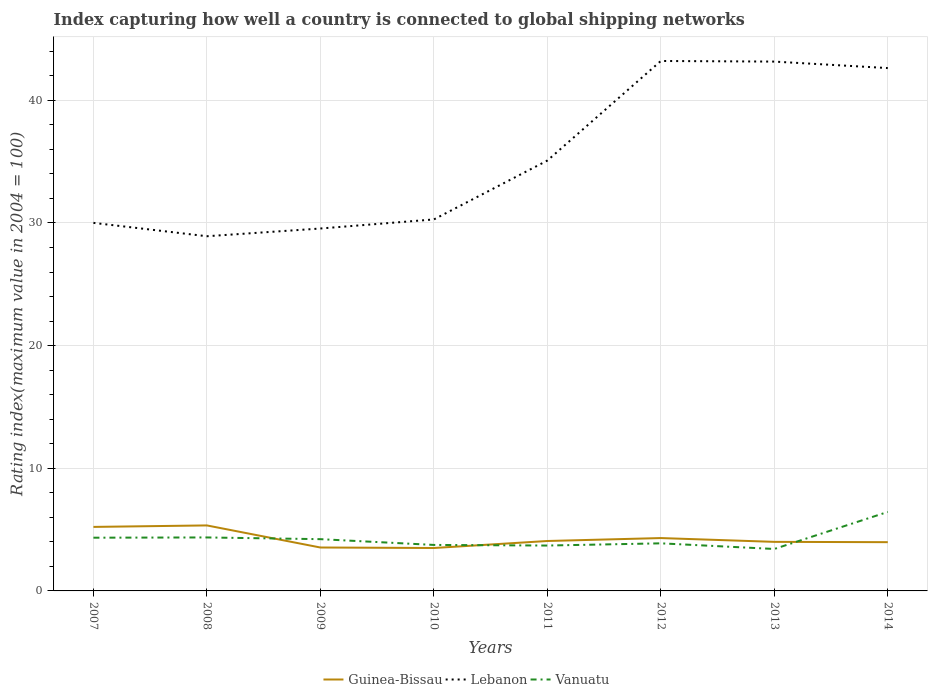How many different coloured lines are there?
Your answer should be very brief. 3. Does the line corresponding to Vanuatu intersect with the line corresponding to Lebanon?
Your answer should be compact. No. Is the number of lines equal to the number of legend labels?
Offer a very short reply. Yes. Across all years, what is the maximum rating index in Guinea-Bissau?
Your answer should be very brief. 3.5. What is the total rating index in Lebanon in the graph?
Offer a very short reply. -12.92. What is the difference between the highest and the second highest rating index in Guinea-Bissau?
Give a very brief answer. 1.84. Is the rating index in Vanuatu strictly greater than the rating index in Lebanon over the years?
Give a very brief answer. Yes. How many years are there in the graph?
Keep it short and to the point. 8. What is the difference between two consecutive major ticks on the Y-axis?
Keep it short and to the point. 10. Does the graph contain any zero values?
Keep it short and to the point. No. Where does the legend appear in the graph?
Make the answer very short. Bottom center. How are the legend labels stacked?
Provide a succinct answer. Horizontal. What is the title of the graph?
Your response must be concise. Index capturing how well a country is connected to global shipping networks. What is the label or title of the Y-axis?
Keep it short and to the point. Rating index(maximum value in 2004 = 100). What is the Rating index(maximum value in 2004 = 100) of Guinea-Bissau in 2007?
Provide a short and direct response. 5.22. What is the Rating index(maximum value in 2004 = 100) of Lebanon in 2007?
Provide a succinct answer. 30.01. What is the Rating index(maximum value in 2004 = 100) in Vanuatu in 2007?
Ensure brevity in your answer.  4.34. What is the Rating index(maximum value in 2004 = 100) of Guinea-Bissau in 2008?
Give a very brief answer. 5.34. What is the Rating index(maximum value in 2004 = 100) of Lebanon in 2008?
Provide a short and direct response. 28.92. What is the Rating index(maximum value in 2004 = 100) in Vanuatu in 2008?
Your answer should be compact. 4.36. What is the Rating index(maximum value in 2004 = 100) of Guinea-Bissau in 2009?
Offer a very short reply. 3.54. What is the Rating index(maximum value in 2004 = 100) in Lebanon in 2009?
Provide a short and direct response. 29.55. What is the Rating index(maximum value in 2004 = 100) of Vanuatu in 2009?
Your answer should be very brief. 4.22. What is the Rating index(maximum value in 2004 = 100) in Lebanon in 2010?
Make the answer very short. 30.29. What is the Rating index(maximum value in 2004 = 100) in Vanuatu in 2010?
Your response must be concise. 3.75. What is the Rating index(maximum value in 2004 = 100) of Guinea-Bissau in 2011?
Your answer should be very brief. 4.07. What is the Rating index(maximum value in 2004 = 100) of Lebanon in 2011?
Offer a terse response. 35.09. What is the Rating index(maximum value in 2004 = 100) in Guinea-Bissau in 2012?
Give a very brief answer. 4.31. What is the Rating index(maximum value in 2004 = 100) in Lebanon in 2012?
Ensure brevity in your answer.  43.21. What is the Rating index(maximum value in 2004 = 100) of Vanuatu in 2012?
Offer a terse response. 3.88. What is the Rating index(maximum value in 2004 = 100) in Guinea-Bissau in 2013?
Your answer should be very brief. 4. What is the Rating index(maximum value in 2004 = 100) in Lebanon in 2013?
Your answer should be very brief. 43.16. What is the Rating index(maximum value in 2004 = 100) of Vanuatu in 2013?
Your answer should be very brief. 3.42. What is the Rating index(maximum value in 2004 = 100) of Guinea-Bissau in 2014?
Your answer should be very brief. 3.97. What is the Rating index(maximum value in 2004 = 100) of Lebanon in 2014?
Your response must be concise. 42.63. What is the Rating index(maximum value in 2004 = 100) in Vanuatu in 2014?
Make the answer very short. 6.44. Across all years, what is the maximum Rating index(maximum value in 2004 = 100) in Guinea-Bissau?
Give a very brief answer. 5.34. Across all years, what is the maximum Rating index(maximum value in 2004 = 100) of Lebanon?
Your response must be concise. 43.21. Across all years, what is the maximum Rating index(maximum value in 2004 = 100) of Vanuatu?
Your response must be concise. 6.44. Across all years, what is the minimum Rating index(maximum value in 2004 = 100) of Lebanon?
Keep it short and to the point. 28.92. Across all years, what is the minimum Rating index(maximum value in 2004 = 100) of Vanuatu?
Your answer should be very brief. 3.42. What is the total Rating index(maximum value in 2004 = 100) of Guinea-Bissau in the graph?
Ensure brevity in your answer.  33.95. What is the total Rating index(maximum value in 2004 = 100) in Lebanon in the graph?
Provide a succinct answer. 282.86. What is the total Rating index(maximum value in 2004 = 100) of Vanuatu in the graph?
Provide a succinct answer. 34.11. What is the difference between the Rating index(maximum value in 2004 = 100) of Guinea-Bissau in 2007 and that in 2008?
Provide a short and direct response. -0.12. What is the difference between the Rating index(maximum value in 2004 = 100) of Lebanon in 2007 and that in 2008?
Offer a terse response. 1.09. What is the difference between the Rating index(maximum value in 2004 = 100) in Vanuatu in 2007 and that in 2008?
Your answer should be very brief. -0.02. What is the difference between the Rating index(maximum value in 2004 = 100) of Guinea-Bissau in 2007 and that in 2009?
Offer a terse response. 1.68. What is the difference between the Rating index(maximum value in 2004 = 100) in Lebanon in 2007 and that in 2009?
Offer a very short reply. 0.46. What is the difference between the Rating index(maximum value in 2004 = 100) in Vanuatu in 2007 and that in 2009?
Your response must be concise. 0.12. What is the difference between the Rating index(maximum value in 2004 = 100) in Guinea-Bissau in 2007 and that in 2010?
Your answer should be compact. 1.72. What is the difference between the Rating index(maximum value in 2004 = 100) of Lebanon in 2007 and that in 2010?
Keep it short and to the point. -0.28. What is the difference between the Rating index(maximum value in 2004 = 100) in Vanuatu in 2007 and that in 2010?
Your answer should be very brief. 0.59. What is the difference between the Rating index(maximum value in 2004 = 100) in Guinea-Bissau in 2007 and that in 2011?
Make the answer very short. 1.15. What is the difference between the Rating index(maximum value in 2004 = 100) in Lebanon in 2007 and that in 2011?
Keep it short and to the point. -5.08. What is the difference between the Rating index(maximum value in 2004 = 100) of Vanuatu in 2007 and that in 2011?
Offer a very short reply. 0.64. What is the difference between the Rating index(maximum value in 2004 = 100) in Guinea-Bissau in 2007 and that in 2012?
Make the answer very short. 0.91. What is the difference between the Rating index(maximum value in 2004 = 100) in Vanuatu in 2007 and that in 2012?
Offer a terse response. 0.46. What is the difference between the Rating index(maximum value in 2004 = 100) in Guinea-Bissau in 2007 and that in 2013?
Ensure brevity in your answer.  1.22. What is the difference between the Rating index(maximum value in 2004 = 100) of Lebanon in 2007 and that in 2013?
Give a very brief answer. -13.15. What is the difference between the Rating index(maximum value in 2004 = 100) of Guinea-Bissau in 2007 and that in 2014?
Provide a succinct answer. 1.25. What is the difference between the Rating index(maximum value in 2004 = 100) in Lebanon in 2007 and that in 2014?
Make the answer very short. -12.62. What is the difference between the Rating index(maximum value in 2004 = 100) of Vanuatu in 2007 and that in 2014?
Provide a short and direct response. -2.1. What is the difference between the Rating index(maximum value in 2004 = 100) of Lebanon in 2008 and that in 2009?
Keep it short and to the point. -0.63. What is the difference between the Rating index(maximum value in 2004 = 100) in Vanuatu in 2008 and that in 2009?
Your response must be concise. 0.14. What is the difference between the Rating index(maximum value in 2004 = 100) in Guinea-Bissau in 2008 and that in 2010?
Your answer should be compact. 1.84. What is the difference between the Rating index(maximum value in 2004 = 100) in Lebanon in 2008 and that in 2010?
Keep it short and to the point. -1.37. What is the difference between the Rating index(maximum value in 2004 = 100) of Vanuatu in 2008 and that in 2010?
Make the answer very short. 0.61. What is the difference between the Rating index(maximum value in 2004 = 100) in Guinea-Bissau in 2008 and that in 2011?
Provide a short and direct response. 1.27. What is the difference between the Rating index(maximum value in 2004 = 100) in Lebanon in 2008 and that in 2011?
Provide a succinct answer. -6.17. What is the difference between the Rating index(maximum value in 2004 = 100) of Vanuatu in 2008 and that in 2011?
Provide a succinct answer. 0.66. What is the difference between the Rating index(maximum value in 2004 = 100) in Lebanon in 2008 and that in 2012?
Your answer should be very brief. -14.29. What is the difference between the Rating index(maximum value in 2004 = 100) in Vanuatu in 2008 and that in 2012?
Keep it short and to the point. 0.48. What is the difference between the Rating index(maximum value in 2004 = 100) of Guinea-Bissau in 2008 and that in 2013?
Provide a succinct answer. 1.34. What is the difference between the Rating index(maximum value in 2004 = 100) in Lebanon in 2008 and that in 2013?
Your answer should be very brief. -14.24. What is the difference between the Rating index(maximum value in 2004 = 100) of Guinea-Bissau in 2008 and that in 2014?
Ensure brevity in your answer.  1.37. What is the difference between the Rating index(maximum value in 2004 = 100) of Lebanon in 2008 and that in 2014?
Offer a terse response. -13.71. What is the difference between the Rating index(maximum value in 2004 = 100) in Vanuatu in 2008 and that in 2014?
Ensure brevity in your answer.  -2.08. What is the difference between the Rating index(maximum value in 2004 = 100) in Guinea-Bissau in 2009 and that in 2010?
Provide a succinct answer. 0.04. What is the difference between the Rating index(maximum value in 2004 = 100) in Lebanon in 2009 and that in 2010?
Make the answer very short. -0.74. What is the difference between the Rating index(maximum value in 2004 = 100) of Vanuatu in 2009 and that in 2010?
Give a very brief answer. 0.47. What is the difference between the Rating index(maximum value in 2004 = 100) in Guinea-Bissau in 2009 and that in 2011?
Provide a succinct answer. -0.53. What is the difference between the Rating index(maximum value in 2004 = 100) of Lebanon in 2009 and that in 2011?
Ensure brevity in your answer.  -5.54. What is the difference between the Rating index(maximum value in 2004 = 100) in Vanuatu in 2009 and that in 2011?
Ensure brevity in your answer.  0.52. What is the difference between the Rating index(maximum value in 2004 = 100) in Guinea-Bissau in 2009 and that in 2012?
Your answer should be compact. -0.77. What is the difference between the Rating index(maximum value in 2004 = 100) in Lebanon in 2009 and that in 2012?
Your answer should be compact. -13.66. What is the difference between the Rating index(maximum value in 2004 = 100) of Vanuatu in 2009 and that in 2012?
Offer a terse response. 0.34. What is the difference between the Rating index(maximum value in 2004 = 100) in Guinea-Bissau in 2009 and that in 2013?
Offer a very short reply. -0.46. What is the difference between the Rating index(maximum value in 2004 = 100) of Lebanon in 2009 and that in 2013?
Keep it short and to the point. -13.61. What is the difference between the Rating index(maximum value in 2004 = 100) of Guinea-Bissau in 2009 and that in 2014?
Keep it short and to the point. -0.43. What is the difference between the Rating index(maximum value in 2004 = 100) in Lebanon in 2009 and that in 2014?
Your response must be concise. -13.08. What is the difference between the Rating index(maximum value in 2004 = 100) of Vanuatu in 2009 and that in 2014?
Provide a short and direct response. -2.22. What is the difference between the Rating index(maximum value in 2004 = 100) of Guinea-Bissau in 2010 and that in 2011?
Your answer should be compact. -0.57. What is the difference between the Rating index(maximum value in 2004 = 100) of Lebanon in 2010 and that in 2011?
Your answer should be very brief. -4.8. What is the difference between the Rating index(maximum value in 2004 = 100) of Vanuatu in 2010 and that in 2011?
Your response must be concise. 0.05. What is the difference between the Rating index(maximum value in 2004 = 100) in Guinea-Bissau in 2010 and that in 2012?
Provide a short and direct response. -0.81. What is the difference between the Rating index(maximum value in 2004 = 100) in Lebanon in 2010 and that in 2012?
Ensure brevity in your answer.  -12.92. What is the difference between the Rating index(maximum value in 2004 = 100) in Vanuatu in 2010 and that in 2012?
Your answer should be compact. -0.13. What is the difference between the Rating index(maximum value in 2004 = 100) in Lebanon in 2010 and that in 2013?
Ensure brevity in your answer.  -12.87. What is the difference between the Rating index(maximum value in 2004 = 100) of Vanuatu in 2010 and that in 2013?
Offer a very short reply. 0.33. What is the difference between the Rating index(maximum value in 2004 = 100) in Guinea-Bissau in 2010 and that in 2014?
Your answer should be very brief. -0.47. What is the difference between the Rating index(maximum value in 2004 = 100) of Lebanon in 2010 and that in 2014?
Your answer should be compact. -12.34. What is the difference between the Rating index(maximum value in 2004 = 100) of Vanuatu in 2010 and that in 2014?
Ensure brevity in your answer.  -2.69. What is the difference between the Rating index(maximum value in 2004 = 100) of Guinea-Bissau in 2011 and that in 2012?
Your answer should be very brief. -0.24. What is the difference between the Rating index(maximum value in 2004 = 100) in Lebanon in 2011 and that in 2012?
Your response must be concise. -8.12. What is the difference between the Rating index(maximum value in 2004 = 100) of Vanuatu in 2011 and that in 2012?
Your response must be concise. -0.18. What is the difference between the Rating index(maximum value in 2004 = 100) of Guinea-Bissau in 2011 and that in 2013?
Offer a terse response. 0.07. What is the difference between the Rating index(maximum value in 2004 = 100) in Lebanon in 2011 and that in 2013?
Make the answer very short. -8.07. What is the difference between the Rating index(maximum value in 2004 = 100) in Vanuatu in 2011 and that in 2013?
Offer a terse response. 0.28. What is the difference between the Rating index(maximum value in 2004 = 100) in Guinea-Bissau in 2011 and that in 2014?
Give a very brief answer. 0.1. What is the difference between the Rating index(maximum value in 2004 = 100) in Lebanon in 2011 and that in 2014?
Keep it short and to the point. -7.54. What is the difference between the Rating index(maximum value in 2004 = 100) of Vanuatu in 2011 and that in 2014?
Provide a short and direct response. -2.74. What is the difference between the Rating index(maximum value in 2004 = 100) of Guinea-Bissau in 2012 and that in 2013?
Provide a short and direct response. 0.31. What is the difference between the Rating index(maximum value in 2004 = 100) in Lebanon in 2012 and that in 2013?
Your answer should be compact. 0.05. What is the difference between the Rating index(maximum value in 2004 = 100) of Vanuatu in 2012 and that in 2013?
Offer a terse response. 0.46. What is the difference between the Rating index(maximum value in 2004 = 100) of Guinea-Bissau in 2012 and that in 2014?
Offer a very short reply. 0.34. What is the difference between the Rating index(maximum value in 2004 = 100) of Lebanon in 2012 and that in 2014?
Keep it short and to the point. 0.58. What is the difference between the Rating index(maximum value in 2004 = 100) of Vanuatu in 2012 and that in 2014?
Make the answer very short. -2.56. What is the difference between the Rating index(maximum value in 2004 = 100) of Guinea-Bissau in 2013 and that in 2014?
Provide a succinct answer. 0.03. What is the difference between the Rating index(maximum value in 2004 = 100) in Lebanon in 2013 and that in 2014?
Your answer should be compact. 0.53. What is the difference between the Rating index(maximum value in 2004 = 100) of Vanuatu in 2013 and that in 2014?
Ensure brevity in your answer.  -3.02. What is the difference between the Rating index(maximum value in 2004 = 100) of Guinea-Bissau in 2007 and the Rating index(maximum value in 2004 = 100) of Lebanon in 2008?
Your answer should be compact. -23.7. What is the difference between the Rating index(maximum value in 2004 = 100) in Guinea-Bissau in 2007 and the Rating index(maximum value in 2004 = 100) in Vanuatu in 2008?
Offer a terse response. 0.86. What is the difference between the Rating index(maximum value in 2004 = 100) of Lebanon in 2007 and the Rating index(maximum value in 2004 = 100) of Vanuatu in 2008?
Offer a terse response. 25.65. What is the difference between the Rating index(maximum value in 2004 = 100) in Guinea-Bissau in 2007 and the Rating index(maximum value in 2004 = 100) in Lebanon in 2009?
Make the answer very short. -24.33. What is the difference between the Rating index(maximum value in 2004 = 100) of Lebanon in 2007 and the Rating index(maximum value in 2004 = 100) of Vanuatu in 2009?
Make the answer very short. 25.79. What is the difference between the Rating index(maximum value in 2004 = 100) of Guinea-Bissau in 2007 and the Rating index(maximum value in 2004 = 100) of Lebanon in 2010?
Keep it short and to the point. -25.07. What is the difference between the Rating index(maximum value in 2004 = 100) in Guinea-Bissau in 2007 and the Rating index(maximum value in 2004 = 100) in Vanuatu in 2010?
Give a very brief answer. 1.47. What is the difference between the Rating index(maximum value in 2004 = 100) in Lebanon in 2007 and the Rating index(maximum value in 2004 = 100) in Vanuatu in 2010?
Provide a short and direct response. 26.26. What is the difference between the Rating index(maximum value in 2004 = 100) of Guinea-Bissau in 2007 and the Rating index(maximum value in 2004 = 100) of Lebanon in 2011?
Your answer should be very brief. -29.87. What is the difference between the Rating index(maximum value in 2004 = 100) in Guinea-Bissau in 2007 and the Rating index(maximum value in 2004 = 100) in Vanuatu in 2011?
Ensure brevity in your answer.  1.52. What is the difference between the Rating index(maximum value in 2004 = 100) of Lebanon in 2007 and the Rating index(maximum value in 2004 = 100) of Vanuatu in 2011?
Your answer should be compact. 26.31. What is the difference between the Rating index(maximum value in 2004 = 100) in Guinea-Bissau in 2007 and the Rating index(maximum value in 2004 = 100) in Lebanon in 2012?
Keep it short and to the point. -37.99. What is the difference between the Rating index(maximum value in 2004 = 100) in Guinea-Bissau in 2007 and the Rating index(maximum value in 2004 = 100) in Vanuatu in 2012?
Provide a short and direct response. 1.34. What is the difference between the Rating index(maximum value in 2004 = 100) in Lebanon in 2007 and the Rating index(maximum value in 2004 = 100) in Vanuatu in 2012?
Provide a succinct answer. 26.13. What is the difference between the Rating index(maximum value in 2004 = 100) of Guinea-Bissau in 2007 and the Rating index(maximum value in 2004 = 100) of Lebanon in 2013?
Make the answer very short. -37.94. What is the difference between the Rating index(maximum value in 2004 = 100) of Lebanon in 2007 and the Rating index(maximum value in 2004 = 100) of Vanuatu in 2013?
Provide a short and direct response. 26.59. What is the difference between the Rating index(maximum value in 2004 = 100) of Guinea-Bissau in 2007 and the Rating index(maximum value in 2004 = 100) of Lebanon in 2014?
Your response must be concise. -37.41. What is the difference between the Rating index(maximum value in 2004 = 100) in Guinea-Bissau in 2007 and the Rating index(maximum value in 2004 = 100) in Vanuatu in 2014?
Your answer should be very brief. -1.22. What is the difference between the Rating index(maximum value in 2004 = 100) of Lebanon in 2007 and the Rating index(maximum value in 2004 = 100) of Vanuatu in 2014?
Provide a short and direct response. 23.57. What is the difference between the Rating index(maximum value in 2004 = 100) of Guinea-Bissau in 2008 and the Rating index(maximum value in 2004 = 100) of Lebanon in 2009?
Your response must be concise. -24.21. What is the difference between the Rating index(maximum value in 2004 = 100) in Guinea-Bissau in 2008 and the Rating index(maximum value in 2004 = 100) in Vanuatu in 2009?
Keep it short and to the point. 1.12. What is the difference between the Rating index(maximum value in 2004 = 100) of Lebanon in 2008 and the Rating index(maximum value in 2004 = 100) of Vanuatu in 2009?
Give a very brief answer. 24.7. What is the difference between the Rating index(maximum value in 2004 = 100) in Guinea-Bissau in 2008 and the Rating index(maximum value in 2004 = 100) in Lebanon in 2010?
Offer a terse response. -24.95. What is the difference between the Rating index(maximum value in 2004 = 100) of Guinea-Bissau in 2008 and the Rating index(maximum value in 2004 = 100) of Vanuatu in 2010?
Ensure brevity in your answer.  1.59. What is the difference between the Rating index(maximum value in 2004 = 100) of Lebanon in 2008 and the Rating index(maximum value in 2004 = 100) of Vanuatu in 2010?
Offer a very short reply. 25.17. What is the difference between the Rating index(maximum value in 2004 = 100) in Guinea-Bissau in 2008 and the Rating index(maximum value in 2004 = 100) in Lebanon in 2011?
Your answer should be compact. -29.75. What is the difference between the Rating index(maximum value in 2004 = 100) of Guinea-Bissau in 2008 and the Rating index(maximum value in 2004 = 100) of Vanuatu in 2011?
Keep it short and to the point. 1.64. What is the difference between the Rating index(maximum value in 2004 = 100) in Lebanon in 2008 and the Rating index(maximum value in 2004 = 100) in Vanuatu in 2011?
Your response must be concise. 25.22. What is the difference between the Rating index(maximum value in 2004 = 100) of Guinea-Bissau in 2008 and the Rating index(maximum value in 2004 = 100) of Lebanon in 2012?
Offer a very short reply. -37.87. What is the difference between the Rating index(maximum value in 2004 = 100) of Guinea-Bissau in 2008 and the Rating index(maximum value in 2004 = 100) of Vanuatu in 2012?
Provide a short and direct response. 1.46. What is the difference between the Rating index(maximum value in 2004 = 100) in Lebanon in 2008 and the Rating index(maximum value in 2004 = 100) in Vanuatu in 2012?
Your answer should be very brief. 25.04. What is the difference between the Rating index(maximum value in 2004 = 100) of Guinea-Bissau in 2008 and the Rating index(maximum value in 2004 = 100) of Lebanon in 2013?
Give a very brief answer. -37.82. What is the difference between the Rating index(maximum value in 2004 = 100) in Guinea-Bissau in 2008 and the Rating index(maximum value in 2004 = 100) in Vanuatu in 2013?
Give a very brief answer. 1.92. What is the difference between the Rating index(maximum value in 2004 = 100) of Guinea-Bissau in 2008 and the Rating index(maximum value in 2004 = 100) of Lebanon in 2014?
Keep it short and to the point. -37.29. What is the difference between the Rating index(maximum value in 2004 = 100) of Guinea-Bissau in 2008 and the Rating index(maximum value in 2004 = 100) of Vanuatu in 2014?
Offer a terse response. -1.1. What is the difference between the Rating index(maximum value in 2004 = 100) of Lebanon in 2008 and the Rating index(maximum value in 2004 = 100) of Vanuatu in 2014?
Offer a terse response. 22.48. What is the difference between the Rating index(maximum value in 2004 = 100) in Guinea-Bissau in 2009 and the Rating index(maximum value in 2004 = 100) in Lebanon in 2010?
Provide a short and direct response. -26.75. What is the difference between the Rating index(maximum value in 2004 = 100) in Guinea-Bissau in 2009 and the Rating index(maximum value in 2004 = 100) in Vanuatu in 2010?
Ensure brevity in your answer.  -0.21. What is the difference between the Rating index(maximum value in 2004 = 100) in Lebanon in 2009 and the Rating index(maximum value in 2004 = 100) in Vanuatu in 2010?
Make the answer very short. 25.8. What is the difference between the Rating index(maximum value in 2004 = 100) of Guinea-Bissau in 2009 and the Rating index(maximum value in 2004 = 100) of Lebanon in 2011?
Your answer should be very brief. -31.55. What is the difference between the Rating index(maximum value in 2004 = 100) of Guinea-Bissau in 2009 and the Rating index(maximum value in 2004 = 100) of Vanuatu in 2011?
Your answer should be compact. -0.16. What is the difference between the Rating index(maximum value in 2004 = 100) of Lebanon in 2009 and the Rating index(maximum value in 2004 = 100) of Vanuatu in 2011?
Make the answer very short. 25.85. What is the difference between the Rating index(maximum value in 2004 = 100) in Guinea-Bissau in 2009 and the Rating index(maximum value in 2004 = 100) in Lebanon in 2012?
Offer a very short reply. -39.67. What is the difference between the Rating index(maximum value in 2004 = 100) in Guinea-Bissau in 2009 and the Rating index(maximum value in 2004 = 100) in Vanuatu in 2012?
Offer a terse response. -0.34. What is the difference between the Rating index(maximum value in 2004 = 100) of Lebanon in 2009 and the Rating index(maximum value in 2004 = 100) of Vanuatu in 2012?
Make the answer very short. 25.67. What is the difference between the Rating index(maximum value in 2004 = 100) of Guinea-Bissau in 2009 and the Rating index(maximum value in 2004 = 100) of Lebanon in 2013?
Your answer should be compact. -39.62. What is the difference between the Rating index(maximum value in 2004 = 100) in Guinea-Bissau in 2009 and the Rating index(maximum value in 2004 = 100) in Vanuatu in 2013?
Keep it short and to the point. 0.12. What is the difference between the Rating index(maximum value in 2004 = 100) in Lebanon in 2009 and the Rating index(maximum value in 2004 = 100) in Vanuatu in 2013?
Offer a terse response. 26.13. What is the difference between the Rating index(maximum value in 2004 = 100) of Guinea-Bissau in 2009 and the Rating index(maximum value in 2004 = 100) of Lebanon in 2014?
Your response must be concise. -39.09. What is the difference between the Rating index(maximum value in 2004 = 100) of Guinea-Bissau in 2009 and the Rating index(maximum value in 2004 = 100) of Vanuatu in 2014?
Your response must be concise. -2.9. What is the difference between the Rating index(maximum value in 2004 = 100) of Lebanon in 2009 and the Rating index(maximum value in 2004 = 100) of Vanuatu in 2014?
Your response must be concise. 23.11. What is the difference between the Rating index(maximum value in 2004 = 100) of Guinea-Bissau in 2010 and the Rating index(maximum value in 2004 = 100) of Lebanon in 2011?
Make the answer very short. -31.59. What is the difference between the Rating index(maximum value in 2004 = 100) in Guinea-Bissau in 2010 and the Rating index(maximum value in 2004 = 100) in Vanuatu in 2011?
Make the answer very short. -0.2. What is the difference between the Rating index(maximum value in 2004 = 100) in Lebanon in 2010 and the Rating index(maximum value in 2004 = 100) in Vanuatu in 2011?
Ensure brevity in your answer.  26.59. What is the difference between the Rating index(maximum value in 2004 = 100) in Guinea-Bissau in 2010 and the Rating index(maximum value in 2004 = 100) in Lebanon in 2012?
Give a very brief answer. -39.71. What is the difference between the Rating index(maximum value in 2004 = 100) of Guinea-Bissau in 2010 and the Rating index(maximum value in 2004 = 100) of Vanuatu in 2012?
Your answer should be very brief. -0.38. What is the difference between the Rating index(maximum value in 2004 = 100) in Lebanon in 2010 and the Rating index(maximum value in 2004 = 100) in Vanuatu in 2012?
Your answer should be compact. 26.41. What is the difference between the Rating index(maximum value in 2004 = 100) of Guinea-Bissau in 2010 and the Rating index(maximum value in 2004 = 100) of Lebanon in 2013?
Provide a short and direct response. -39.66. What is the difference between the Rating index(maximum value in 2004 = 100) in Lebanon in 2010 and the Rating index(maximum value in 2004 = 100) in Vanuatu in 2013?
Your response must be concise. 26.87. What is the difference between the Rating index(maximum value in 2004 = 100) of Guinea-Bissau in 2010 and the Rating index(maximum value in 2004 = 100) of Lebanon in 2014?
Provide a short and direct response. -39.13. What is the difference between the Rating index(maximum value in 2004 = 100) of Guinea-Bissau in 2010 and the Rating index(maximum value in 2004 = 100) of Vanuatu in 2014?
Ensure brevity in your answer.  -2.94. What is the difference between the Rating index(maximum value in 2004 = 100) of Lebanon in 2010 and the Rating index(maximum value in 2004 = 100) of Vanuatu in 2014?
Ensure brevity in your answer.  23.85. What is the difference between the Rating index(maximum value in 2004 = 100) of Guinea-Bissau in 2011 and the Rating index(maximum value in 2004 = 100) of Lebanon in 2012?
Give a very brief answer. -39.14. What is the difference between the Rating index(maximum value in 2004 = 100) in Guinea-Bissau in 2011 and the Rating index(maximum value in 2004 = 100) in Vanuatu in 2012?
Offer a very short reply. 0.19. What is the difference between the Rating index(maximum value in 2004 = 100) of Lebanon in 2011 and the Rating index(maximum value in 2004 = 100) of Vanuatu in 2012?
Your answer should be compact. 31.21. What is the difference between the Rating index(maximum value in 2004 = 100) in Guinea-Bissau in 2011 and the Rating index(maximum value in 2004 = 100) in Lebanon in 2013?
Keep it short and to the point. -39.09. What is the difference between the Rating index(maximum value in 2004 = 100) of Guinea-Bissau in 2011 and the Rating index(maximum value in 2004 = 100) of Vanuatu in 2013?
Your answer should be compact. 0.65. What is the difference between the Rating index(maximum value in 2004 = 100) in Lebanon in 2011 and the Rating index(maximum value in 2004 = 100) in Vanuatu in 2013?
Your answer should be very brief. 31.67. What is the difference between the Rating index(maximum value in 2004 = 100) of Guinea-Bissau in 2011 and the Rating index(maximum value in 2004 = 100) of Lebanon in 2014?
Give a very brief answer. -38.56. What is the difference between the Rating index(maximum value in 2004 = 100) in Guinea-Bissau in 2011 and the Rating index(maximum value in 2004 = 100) in Vanuatu in 2014?
Give a very brief answer. -2.37. What is the difference between the Rating index(maximum value in 2004 = 100) of Lebanon in 2011 and the Rating index(maximum value in 2004 = 100) of Vanuatu in 2014?
Give a very brief answer. 28.65. What is the difference between the Rating index(maximum value in 2004 = 100) in Guinea-Bissau in 2012 and the Rating index(maximum value in 2004 = 100) in Lebanon in 2013?
Give a very brief answer. -38.85. What is the difference between the Rating index(maximum value in 2004 = 100) of Guinea-Bissau in 2012 and the Rating index(maximum value in 2004 = 100) of Vanuatu in 2013?
Your response must be concise. 0.89. What is the difference between the Rating index(maximum value in 2004 = 100) of Lebanon in 2012 and the Rating index(maximum value in 2004 = 100) of Vanuatu in 2013?
Provide a succinct answer. 39.79. What is the difference between the Rating index(maximum value in 2004 = 100) of Guinea-Bissau in 2012 and the Rating index(maximum value in 2004 = 100) of Lebanon in 2014?
Keep it short and to the point. -38.32. What is the difference between the Rating index(maximum value in 2004 = 100) of Guinea-Bissau in 2012 and the Rating index(maximum value in 2004 = 100) of Vanuatu in 2014?
Offer a very short reply. -2.13. What is the difference between the Rating index(maximum value in 2004 = 100) in Lebanon in 2012 and the Rating index(maximum value in 2004 = 100) in Vanuatu in 2014?
Ensure brevity in your answer.  36.77. What is the difference between the Rating index(maximum value in 2004 = 100) of Guinea-Bissau in 2013 and the Rating index(maximum value in 2004 = 100) of Lebanon in 2014?
Provide a succinct answer. -38.63. What is the difference between the Rating index(maximum value in 2004 = 100) in Guinea-Bissau in 2013 and the Rating index(maximum value in 2004 = 100) in Vanuatu in 2014?
Offer a terse response. -2.44. What is the difference between the Rating index(maximum value in 2004 = 100) of Lebanon in 2013 and the Rating index(maximum value in 2004 = 100) of Vanuatu in 2014?
Your response must be concise. 36.72. What is the average Rating index(maximum value in 2004 = 100) in Guinea-Bissau per year?
Ensure brevity in your answer.  4.24. What is the average Rating index(maximum value in 2004 = 100) in Lebanon per year?
Provide a succinct answer. 35.36. What is the average Rating index(maximum value in 2004 = 100) of Vanuatu per year?
Your response must be concise. 4.26. In the year 2007, what is the difference between the Rating index(maximum value in 2004 = 100) of Guinea-Bissau and Rating index(maximum value in 2004 = 100) of Lebanon?
Give a very brief answer. -24.79. In the year 2007, what is the difference between the Rating index(maximum value in 2004 = 100) of Lebanon and Rating index(maximum value in 2004 = 100) of Vanuatu?
Keep it short and to the point. 25.67. In the year 2008, what is the difference between the Rating index(maximum value in 2004 = 100) of Guinea-Bissau and Rating index(maximum value in 2004 = 100) of Lebanon?
Ensure brevity in your answer.  -23.58. In the year 2008, what is the difference between the Rating index(maximum value in 2004 = 100) of Lebanon and Rating index(maximum value in 2004 = 100) of Vanuatu?
Make the answer very short. 24.56. In the year 2009, what is the difference between the Rating index(maximum value in 2004 = 100) in Guinea-Bissau and Rating index(maximum value in 2004 = 100) in Lebanon?
Keep it short and to the point. -26.01. In the year 2009, what is the difference between the Rating index(maximum value in 2004 = 100) of Guinea-Bissau and Rating index(maximum value in 2004 = 100) of Vanuatu?
Provide a succinct answer. -0.68. In the year 2009, what is the difference between the Rating index(maximum value in 2004 = 100) of Lebanon and Rating index(maximum value in 2004 = 100) of Vanuatu?
Make the answer very short. 25.33. In the year 2010, what is the difference between the Rating index(maximum value in 2004 = 100) of Guinea-Bissau and Rating index(maximum value in 2004 = 100) of Lebanon?
Offer a very short reply. -26.79. In the year 2010, what is the difference between the Rating index(maximum value in 2004 = 100) of Lebanon and Rating index(maximum value in 2004 = 100) of Vanuatu?
Give a very brief answer. 26.54. In the year 2011, what is the difference between the Rating index(maximum value in 2004 = 100) of Guinea-Bissau and Rating index(maximum value in 2004 = 100) of Lebanon?
Offer a very short reply. -31.02. In the year 2011, what is the difference between the Rating index(maximum value in 2004 = 100) in Guinea-Bissau and Rating index(maximum value in 2004 = 100) in Vanuatu?
Your answer should be compact. 0.37. In the year 2011, what is the difference between the Rating index(maximum value in 2004 = 100) in Lebanon and Rating index(maximum value in 2004 = 100) in Vanuatu?
Give a very brief answer. 31.39. In the year 2012, what is the difference between the Rating index(maximum value in 2004 = 100) in Guinea-Bissau and Rating index(maximum value in 2004 = 100) in Lebanon?
Your answer should be compact. -38.9. In the year 2012, what is the difference between the Rating index(maximum value in 2004 = 100) in Guinea-Bissau and Rating index(maximum value in 2004 = 100) in Vanuatu?
Keep it short and to the point. 0.43. In the year 2012, what is the difference between the Rating index(maximum value in 2004 = 100) in Lebanon and Rating index(maximum value in 2004 = 100) in Vanuatu?
Provide a short and direct response. 39.33. In the year 2013, what is the difference between the Rating index(maximum value in 2004 = 100) in Guinea-Bissau and Rating index(maximum value in 2004 = 100) in Lebanon?
Offer a very short reply. -39.16. In the year 2013, what is the difference between the Rating index(maximum value in 2004 = 100) of Guinea-Bissau and Rating index(maximum value in 2004 = 100) of Vanuatu?
Your response must be concise. 0.58. In the year 2013, what is the difference between the Rating index(maximum value in 2004 = 100) in Lebanon and Rating index(maximum value in 2004 = 100) in Vanuatu?
Provide a succinct answer. 39.74. In the year 2014, what is the difference between the Rating index(maximum value in 2004 = 100) in Guinea-Bissau and Rating index(maximum value in 2004 = 100) in Lebanon?
Provide a succinct answer. -38.66. In the year 2014, what is the difference between the Rating index(maximum value in 2004 = 100) of Guinea-Bissau and Rating index(maximum value in 2004 = 100) of Vanuatu?
Offer a terse response. -2.47. In the year 2014, what is the difference between the Rating index(maximum value in 2004 = 100) in Lebanon and Rating index(maximum value in 2004 = 100) in Vanuatu?
Make the answer very short. 36.19. What is the ratio of the Rating index(maximum value in 2004 = 100) of Guinea-Bissau in 2007 to that in 2008?
Keep it short and to the point. 0.98. What is the ratio of the Rating index(maximum value in 2004 = 100) in Lebanon in 2007 to that in 2008?
Give a very brief answer. 1.04. What is the ratio of the Rating index(maximum value in 2004 = 100) in Vanuatu in 2007 to that in 2008?
Your answer should be compact. 1. What is the ratio of the Rating index(maximum value in 2004 = 100) in Guinea-Bissau in 2007 to that in 2009?
Give a very brief answer. 1.47. What is the ratio of the Rating index(maximum value in 2004 = 100) in Lebanon in 2007 to that in 2009?
Offer a terse response. 1.02. What is the ratio of the Rating index(maximum value in 2004 = 100) of Vanuatu in 2007 to that in 2009?
Your response must be concise. 1.03. What is the ratio of the Rating index(maximum value in 2004 = 100) in Guinea-Bissau in 2007 to that in 2010?
Your response must be concise. 1.49. What is the ratio of the Rating index(maximum value in 2004 = 100) in Vanuatu in 2007 to that in 2010?
Ensure brevity in your answer.  1.16. What is the ratio of the Rating index(maximum value in 2004 = 100) of Guinea-Bissau in 2007 to that in 2011?
Keep it short and to the point. 1.28. What is the ratio of the Rating index(maximum value in 2004 = 100) of Lebanon in 2007 to that in 2011?
Offer a very short reply. 0.86. What is the ratio of the Rating index(maximum value in 2004 = 100) in Vanuatu in 2007 to that in 2011?
Offer a terse response. 1.17. What is the ratio of the Rating index(maximum value in 2004 = 100) in Guinea-Bissau in 2007 to that in 2012?
Make the answer very short. 1.21. What is the ratio of the Rating index(maximum value in 2004 = 100) in Lebanon in 2007 to that in 2012?
Ensure brevity in your answer.  0.69. What is the ratio of the Rating index(maximum value in 2004 = 100) in Vanuatu in 2007 to that in 2012?
Ensure brevity in your answer.  1.12. What is the ratio of the Rating index(maximum value in 2004 = 100) in Guinea-Bissau in 2007 to that in 2013?
Make the answer very short. 1.3. What is the ratio of the Rating index(maximum value in 2004 = 100) in Lebanon in 2007 to that in 2013?
Keep it short and to the point. 0.7. What is the ratio of the Rating index(maximum value in 2004 = 100) of Vanuatu in 2007 to that in 2013?
Give a very brief answer. 1.27. What is the ratio of the Rating index(maximum value in 2004 = 100) in Guinea-Bissau in 2007 to that in 2014?
Provide a short and direct response. 1.31. What is the ratio of the Rating index(maximum value in 2004 = 100) in Lebanon in 2007 to that in 2014?
Offer a very short reply. 0.7. What is the ratio of the Rating index(maximum value in 2004 = 100) of Vanuatu in 2007 to that in 2014?
Provide a succinct answer. 0.67. What is the ratio of the Rating index(maximum value in 2004 = 100) in Guinea-Bissau in 2008 to that in 2009?
Your answer should be very brief. 1.51. What is the ratio of the Rating index(maximum value in 2004 = 100) of Lebanon in 2008 to that in 2009?
Keep it short and to the point. 0.98. What is the ratio of the Rating index(maximum value in 2004 = 100) of Vanuatu in 2008 to that in 2009?
Offer a terse response. 1.03. What is the ratio of the Rating index(maximum value in 2004 = 100) in Guinea-Bissau in 2008 to that in 2010?
Provide a short and direct response. 1.53. What is the ratio of the Rating index(maximum value in 2004 = 100) of Lebanon in 2008 to that in 2010?
Give a very brief answer. 0.95. What is the ratio of the Rating index(maximum value in 2004 = 100) of Vanuatu in 2008 to that in 2010?
Your answer should be compact. 1.16. What is the ratio of the Rating index(maximum value in 2004 = 100) of Guinea-Bissau in 2008 to that in 2011?
Make the answer very short. 1.31. What is the ratio of the Rating index(maximum value in 2004 = 100) of Lebanon in 2008 to that in 2011?
Keep it short and to the point. 0.82. What is the ratio of the Rating index(maximum value in 2004 = 100) of Vanuatu in 2008 to that in 2011?
Ensure brevity in your answer.  1.18. What is the ratio of the Rating index(maximum value in 2004 = 100) in Guinea-Bissau in 2008 to that in 2012?
Make the answer very short. 1.24. What is the ratio of the Rating index(maximum value in 2004 = 100) in Lebanon in 2008 to that in 2012?
Keep it short and to the point. 0.67. What is the ratio of the Rating index(maximum value in 2004 = 100) of Vanuatu in 2008 to that in 2012?
Your answer should be compact. 1.12. What is the ratio of the Rating index(maximum value in 2004 = 100) in Guinea-Bissau in 2008 to that in 2013?
Your response must be concise. 1.33. What is the ratio of the Rating index(maximum value in 2004 = 100) of Lebanon in 2008 to that in 2013?
Give a very brief answer. 0.67. What is the ratio of the Rating index(maximum value in 2004 = 100) of Vanuatu in 2008 to that in 2013?
Your answer should be compact. 1.27. What is the ratio of the Rating index(maximum value in 2004 = 100) of Guinea-Bissau in 2008 to that in 2014?
Keep it short and to the point. 1.34. What is the ratio of the Rating index(maximum value in 2004 = 100) in Lebanon in 2008 to that in 2014?
Your answer should be compact. 0.68. What is the ratio of the Rating index(maximum value in 2004 = 100) in Vanuatu in 2008 to that in 2014?
Offer a very short reply. 0.68. What is the ratio of the Rating index(maximum value in 2004 = 100) of Guinea-Bissau in 2009 to that in 2010?
Ensure brevity in your answer.  1.01. What is the ratio of the Rating index(maximum value in 2004 = 100) of Lebanon in 2009 to that in 2010?
Your answer should be compact. 0.98. What is the ratio of the Rating index(maximum value in 2004 = 100) of Vanuatu in 2009 to that in 2010?
Offer a very short reply. 1.13. What is the ratio of the Rating index(maximum value in 2004 = 100) of Guinea-Bissau in 2009 to that in 2011?
Offer a terse response. 0.87. What is the ratio of the Rating index(maximum value in 2004 = 100) of Lebanon in 2009 to that in 2011?
Offer a very short reply. 0.84. What is the ratio of the Rating index(maximum value in 2004 = 100) of Vanuatu in 2009 to that in 2011?
Keep it short and to the point. 1.14. What is the ratio of the Rating index(maximum value in 2004 = 100) in Guinea-Bissau in 2009 to that in 2012?
Offer a terse response. 0.82. What is the ratio of the Rating index(maximum value in 2004 = 100) in Lebanon in 2009 to that in 2012?
Ensure brevity in your answer.  0.68. What is the ratio of the Rating index(maximum value in 2004 = 100) in Vanuatu in 2009 to that in 2012?
Offer a very short reply. 1.09. What is the ratio of the Rating index(maximum value in 2004 = 100) of Guinea-Bissau in 2009 to that in 2013?
Keep it short and to the point. 0.89. What is the ratio of the Rating index(maximum value in 2004 = 100) in Lebanon in 2009 to that in 2013?
Provide a short and direct response. 0.68. What is the ratio of the Rating index(maximum value in 2004 = 100) in Vanuatu in 2009 to that in 2013?
Give a very brief answer. 1.23. What is the ratio of the Rating index(maximum value in 2004 = 100) of Guinea-Bissau in 2009 to that in 2014?
Offer a terse response. 0.89. What is the ratio of the Rating index(maximum value in 2004 = 100) in Lebanon in 2009 to that in 2014?
Make the answer very short. 0.69. What is the ratio of the Rating index(maximum value in 2004 = 100) of Vanuatu in 2009 to that in 2014?
Offer a very short reply. 0.66. What is the ratio of the Rating index(maximum value in 2004 = 100) of Guinea-Bissau in 2010 to that in 2011?
Keep it short and to the point. 0.86. What is the ratio of the Rating index(maximum value in 2004 = 100) in Lebanon in 2010 to that in 2011?
Provide a short and direct response. 0.86. What is the ratio of the Rating index(maximum value in 2004 = 100) in Vanuatu in 2010 to that in 2011?
Your answer should be compact. 1.01. What is the ratio of the Rating index(maximum value in 2004 = 100) of Guinea-Bissau in 2010 to that in 2012?
Provide a succinct answer. 0.81. What is the ratio of the Rating index(maximum value in 2004 = 100) of Lebanon in 2010 to that in 2012?
Ensure brevity in your answer.  0.7. What is the ratio of the Rating index(maximum value in 2004 = 100) in Vanuatu in 2010 to that in 2012?
Offer a terse response. 0.97. What is the ratio of the Rating index(maximum value in 2004 = 100) of Lebanon in 2010 to that in 2013?
Provide a succinct answer. 0.7. What is the ratio of the Rating index(maximum value in 2004 = 100) of Vanuatu in 2010 to that in 2013?
Offer a terse response. 1.1. What is the ratio of the Rating index(maximum value in 2004 = 100) in Guinea-Bissau in 2010 to that in 2014?
Give a very brief answer. 0.88. What is the ratio of the Rating index(maximum value in 2004 = 100) in Lebanon in 2010 to that in 2014?
Give a very brief answer. 0.71. What is the ratio of the Rating index(maximum value in 2004 = 100) of Vanuatu in 2010 to that in 2014?
Ensure brevity in your answer.  0.58. What is the ratio of the Rating index(maximum value in 2004 = 100) of Guinea-Bissau in 2011 to that in 2012?
Your answer should be compact. 0.94. What is the ratio of the Rating index(maximum value in 2004 = 100) of Lebanon in 2011 to that in 2012?
Your answer should be compact. 0.81. What is the ratio of the Rating index(maximum value in 2004 = 100) of Vanuatu in 2011 to that in 2012?
Ensure brevity in your answer.  0.95. What is the ratio of the Rating index(maximum value in 2004 = 100) in Guinea-Bissau in 2011 to that in 2013?
Provide a short and direct response. 1.02. What is the ratio of the Rating index(maximum value in 2004 = 100) of Lebanon in 2011 to that in 2013?
Your response must be concise. 0.81. What is the ratio of the Rating index(maximum value in 2004 = 100) in Vanuatu in 2011 to that in 2013?
Your answer should be very brief. 1.08. What is the ratio of the Rating index(maximum value in 2004 = 100) in Lebanon in 2011 to that in 2014?
Give a very brief answer. 0.82. What is the ratio of the Rating index(maximum value in 2004 = 100) of Vanuatu in 2011 to that in 2014?
Keep it short and to the point. 0.57. What is the ratio of the Rating index(maximum value in 2004 = 100) of Guinea-Bissau in 2012 to that in 2013?
Provide a short and direct response. 1.08. What is the ratio of the Rating index(maximum value in 2004 = 100) of Lebanon in 2012 to that in 2013?
Make the answer very short. 1. What is the ratio of the Rating index(maximum value in 2004 = 100) of Vanuatu in 2012 to that in 2013?
Offer a terse response. 1.13. What is the ratio of the Rating index(maximum value in 2004 = 100) in Guinea-Bissau in 2012 to that in 2014?
Your answer should be very brief. 1.08. What is the ratio of the Rating index(maximum value in 2004 = 100) in Lebanon in 2012 to that in 2014?
Make the answer very short. 1.01. What is the ratio of the Rating index(maximum value in 2004 = 100) of Vanuatu in 2012 to that in 2014?
Your response must be concise. 0.6. What is the ratio of the Rating index(maximum value in 2004 = 100) of Guinea-Bissau in 2013 to that in 2014?
Offer a terse response. 1.01. What is the ratio of the Rating index(maximum value in 2004 = 100) of Lebanon in 2013 to that in 2014?
Offer a terse response. 1.01. What is the ratio of the Rating index(maximum value in 2004 = 100) of Vanuatu in 2013 to that in 2014?
Provide a succinct answer. 0.53. What is the difference between the highest and the second highest Rating index(maximum value in 2004 = 100) in Guinea-Bissau?
Your answer should be compact. 0.12. What is the difference between the highest and the second highest Rating index(maximum value in 2004 = 100) in Lebanon?
Keep it short and to the point. 0.05. What is the difference between the highest and the second highest Rating index(maximum value in 2004 = 100) in Vanuatu?
Your answer should be compact. 2.08. What is the difference between the highest and the lowest Rating index(maximum value in 2004 = 100) of Guinea-Bissau?
Ensure brevity in your answer.  1.84. What is the difference between the highest and the lowest Rating index(maximum value in 2004 = 100) in Lebanon?
Offer a terse response. 14.29. What is the difference between the highest and the lowest Rating index(maximum value in 2004 = 100) of Vanuatu?
Your response must be concise. 3.02. 